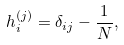Convert formula to latex. <formula><loc_0><loc_0><loc_500><loc_500>h _ { i } ^ { ( j ) } = \delta _ { i j } - \frac { 1 } { N } ,</formula> 